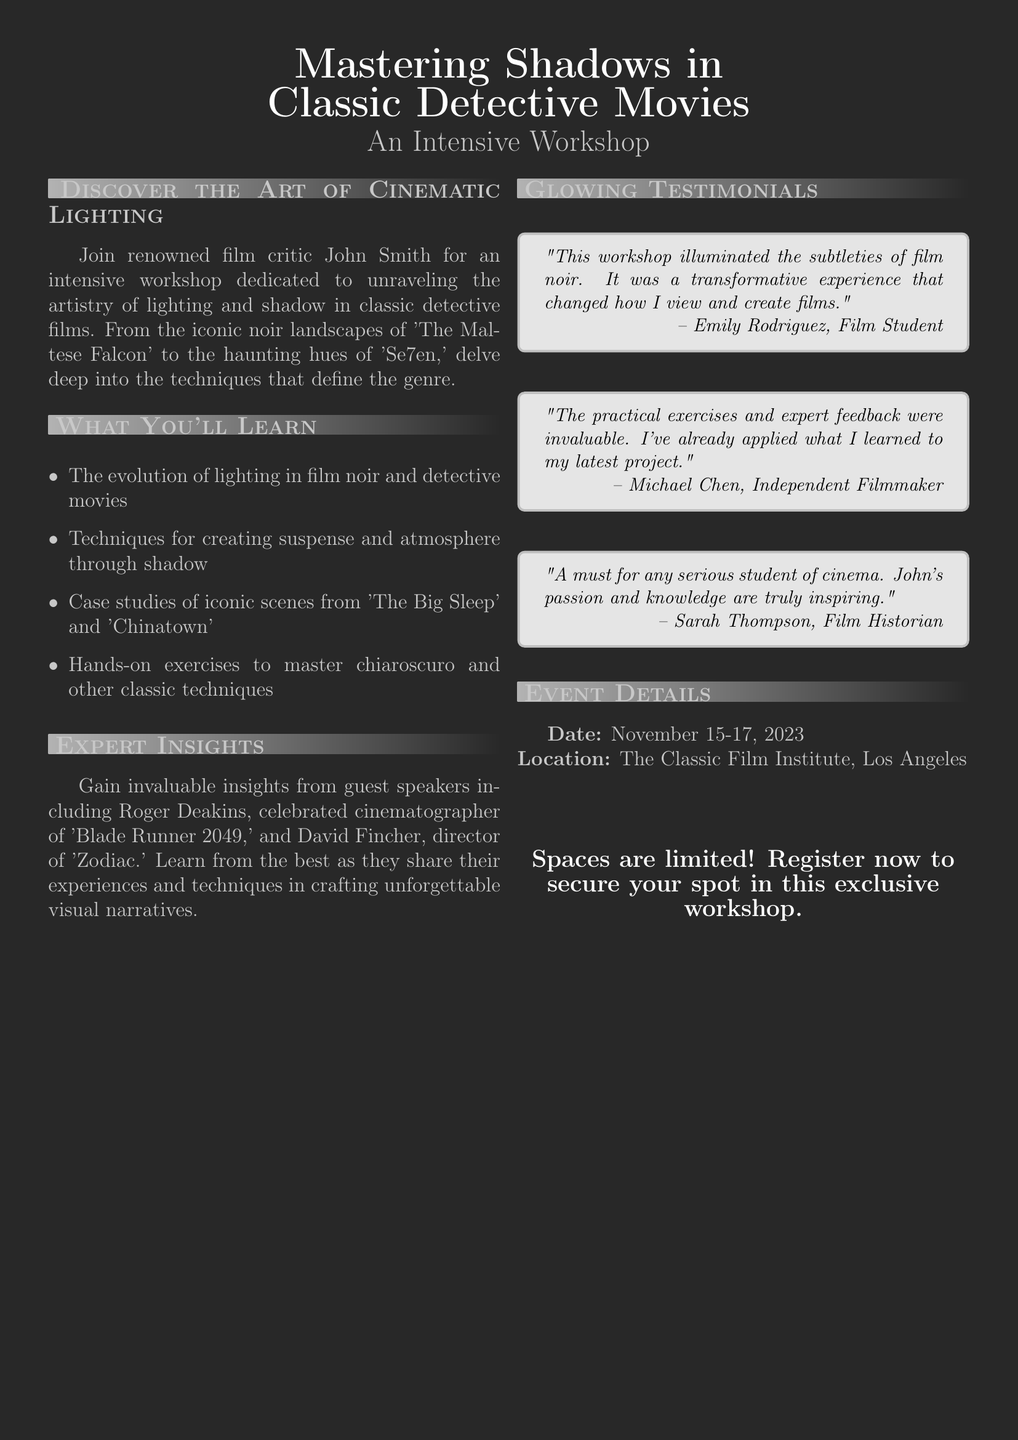what is the name of the workshop? The name of the workshop is highlighted in the title section of the document.
Answer: Mastering Shadows in Classic Detective Movies who is the instructor of the workshop? The instructor's name is mentioned in the section about learning opportunities and expert insights.
Answer: John Smith what are the dates of the workshop? The dates of the workshop are listed in the event details section of the document.
Answer: November 15-17, 2023 where is the workshop taking place? The location of the workshop is provided in the event details section.
Answer: The Classic Film Institute, Los Angeles who are some guest speakers mentioned? The document specifies guest speakers in the expert insights section.
Answer: Roger Deakins and David Fincher how many testimonials are provided in the document? The number of testimonials can be counted from the testimonials section.
Answer: Three what type of techniques will be taught in the workshop? The document lists specific focuses in the "What You'll Learn" section.
Answer: Techniques for creating suspense and atmosphere through shadow which film is referenced as an iconic scene case study? The document mentions specific films in the learning section.
Answer: The Big Sleep is there a limit to the number of participants? The document states a limitation in the registration section.
Answer: Yes, spaces are limited 